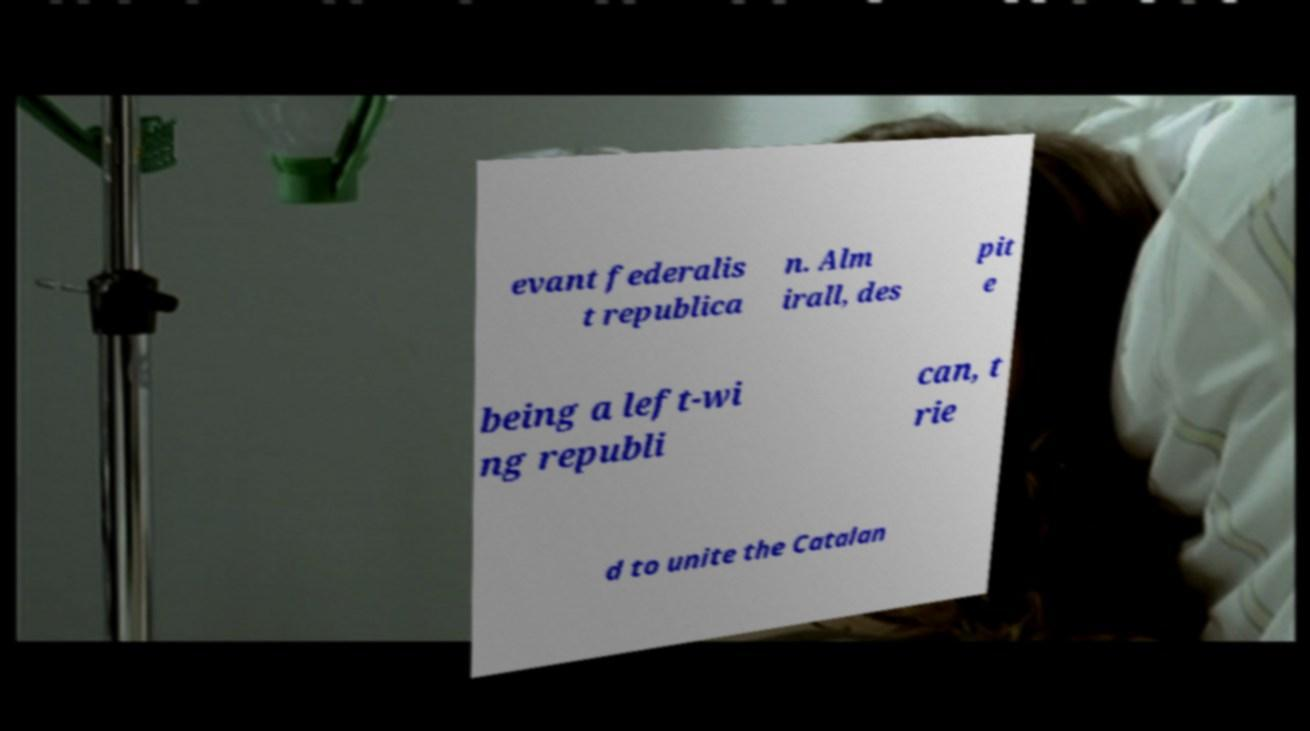Please read and relay the text visible in this image. What does it say? evant federalis t republica n. Alm irall, des pit e being a left-wi ng republi can, t rie d to unite the Catalan 